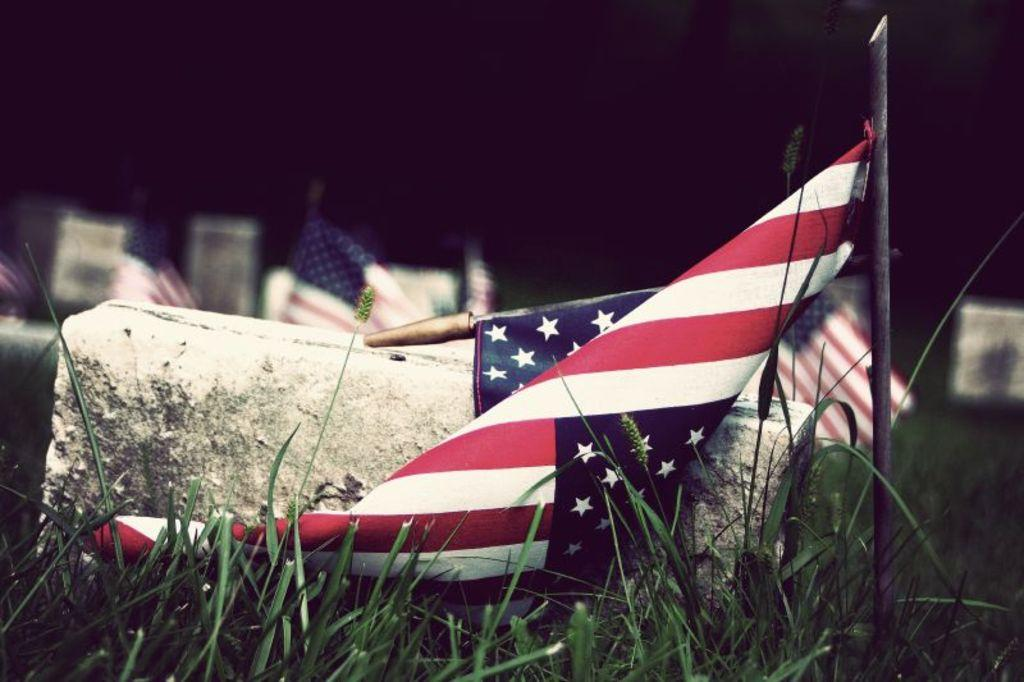What objects are present in the image that represent symbols or affiliations? There are flags in the image. What long, thin objects can be seen in the image? There are sticks in the image. What type of terrain is visible in the image? There is grass in the image. What material is present in the image that is commonly used for construction? There is a brick in the image. How would you describe the appearance of the background in the image? The background of the image is dark and blurred. What type of basketball is visible in the image? There is no basketball present in the image. What type of suit is the person wearing in the image? There is no person or suit present in the image. What type of cart is being used to transport items in the image? There is no cart present in the image. 